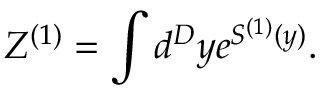<formula> <loc_0><loc_0><loc_500><loc_500>Z ^ { ( 1 ) } = \int d ^ { D } y e ^ { S ^ { ( 1 ) } ( y ) } .</formula> 